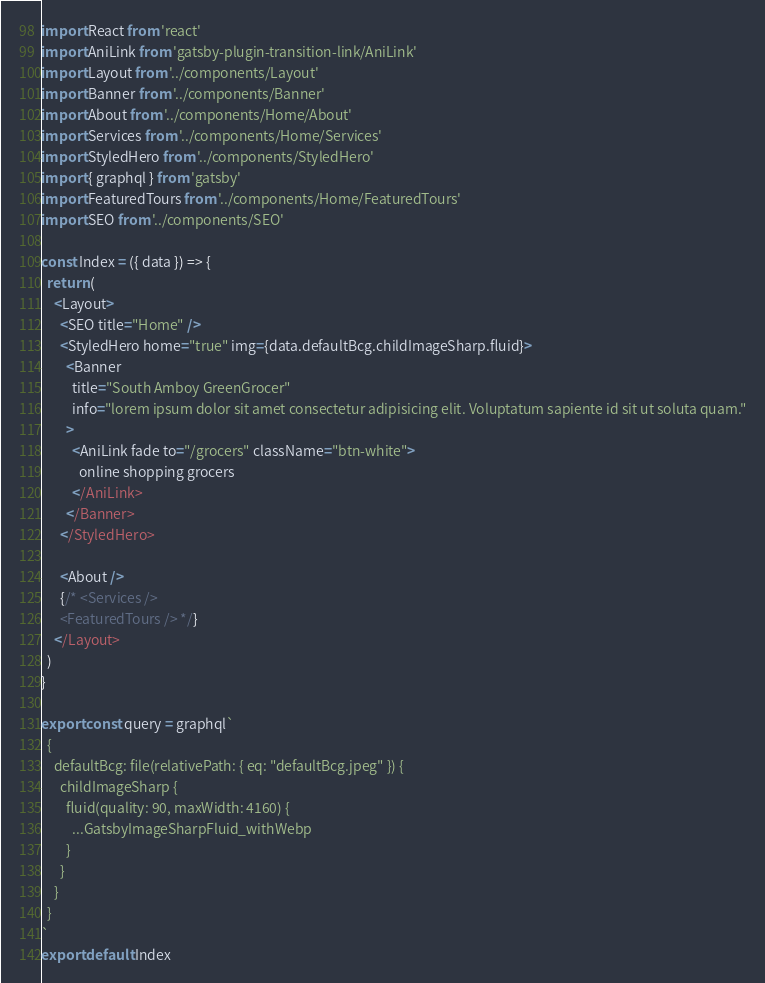<code> <loc_0><loc_0><loc_500><loc_500><_JavaScript_>import React from 'react'
import AniLink from 'gatsby-plugin-transition-link/AniLink'
import Layout from '../components/Layout'
import Banner from '../components/Banner'
import About from '../components/Home/About'
import Services from '../components/Home/Services'
import StyledHero from '../components/StyledHero'
import { graphql } from 'gatsby'
import FeaturedTours from '../components/Home/FeaturedTours'
import SEO from '../components/SEO'

const Index = ({ data }) => {
  return (
    <Layout>
      <SEO title="Home" />
      <StyledHero home="true" img={data.defaultBcg.childImageSharp.fluid}>
        <Banner
          title="South Amboy GreenGrocer"
          info="lorem ipsum dolor sit amet consectetur adipisicing elit. Voluptatum sapiente id sit ut soluta quam."
        >
          <AniLink fade to="/grocers" className="btn-white">
            online shopping grocers
          </AniLink>
        </Banner>
      </StyledHero>

      <About />
      {/* <Services />
      <FeaturedTours /> */}
    </Layout>
  )
}

export const query = graphql`
  {
    defaultBcg: file(relativePath: { eq: "defaultBcg.jpeg" }) {
      childImageSharp {
        fluid(quality: 90, maxWidth: 4160) {
          ...GatsbyImageSharpFluid_withWebp
        }
      }
    }
  }
`
export default Index
</code> 